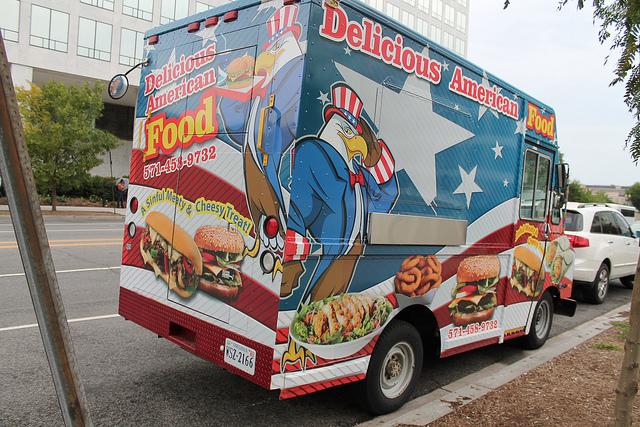What costume is the eagle wearing?
Concise answer only. Uncle sam. What is the name of the food truck?
Keep it brief. Delicious american food. What is delicious and American?
Give a very brief answer. Food. What kind of truck is this?
Concise answer only. Food truck. 